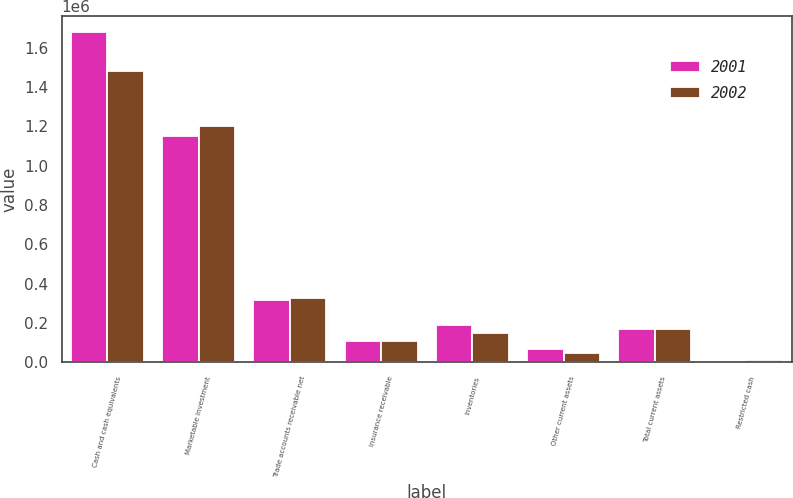Convert chart. <chart><loc_0><loc_0><loc_500><loc_500><stacked_bar_chart><ecel><fcel>Cash and cash equivalents<fcel>Marketable investment<fcel>Trade accounts receivable net<fcel>Insurance receivable<fcel>Inventories<fcel>Other current assets<fcel>Total current assets<fcel>Restricted cash<nl><fcel>2001<fcel>1.67789e+06<fcel>1.15041e+06<fcel>318128<fcel>106000<fcel>190747<fcel>68795<fcel>170518<fcel>1288<nl><fcel>2002<fcel>1.48308e+06<fcel>1.20392e+06<fcel>329020<fcel>106000<fcel>150290<fcel>47212<fcel>170518<fcel>9972<nl></chart> 